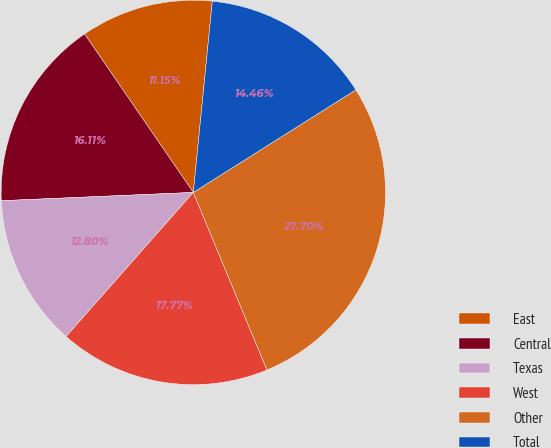Convert chart to OTSL. <chart><loc_0><loc_0><loc_500><loc_500><pie_chart><fcel>East<fcel>Central<fcel>Texas<fcel>West<fcel>Other<fcel>Total<nl><fcel>11.15%<fcel>16.11%<fcel>12.8%<fcel>17.77%<fcel>27.7%<fcel>14.46%<nl></chart> 